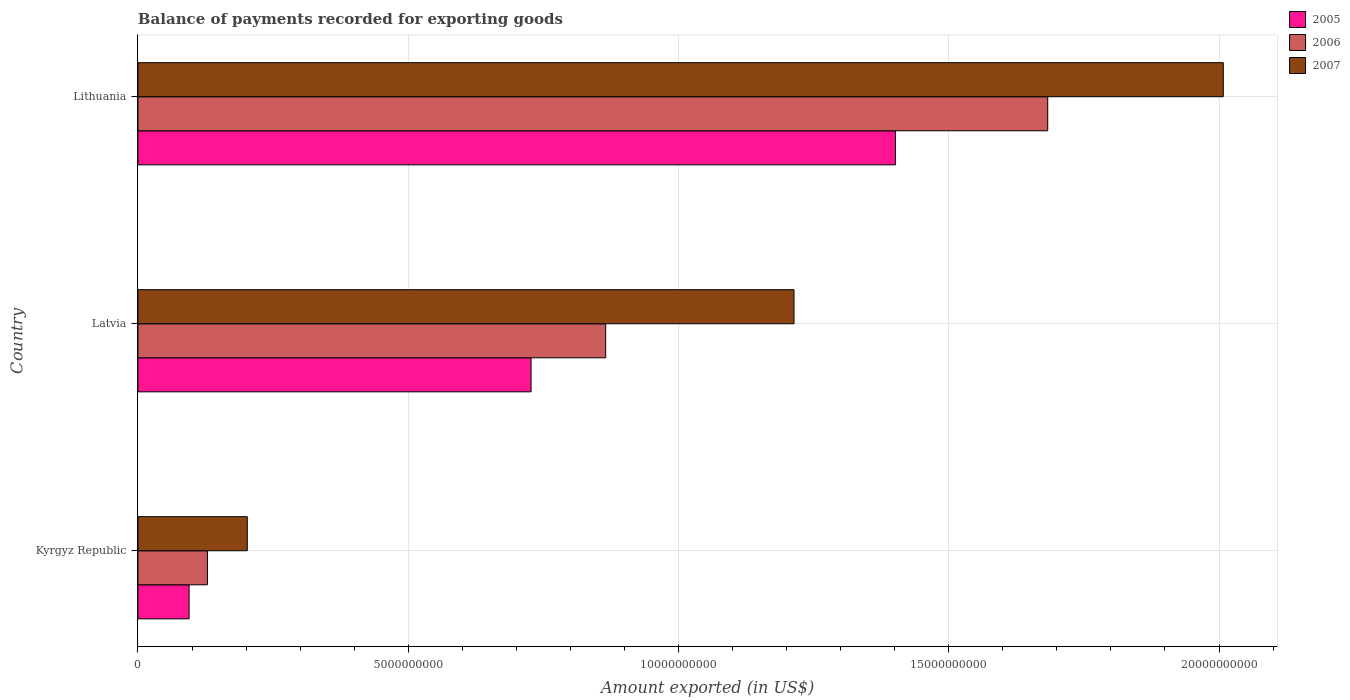How many different coloured bars are there?
Give a very brief answer. 3. Are the number of bars on each tick of the Y-axis equal?
Keep it short and to the point. Yes. How many bars are there on the 1st tick from the top?
Your answer should be compact. 3. What is the label of the 1st group of bars from the top?
Keep it short and to the point. Lithuania. In how many cases, is the number of bars for a given country not equal to the number of legend labels?
Your response must be concise. 0. What is the amount exported in 2005 in Kyrgyz Republic?
Provide a short and direct response. 9.46e+08. Across all countries, what is the maximum amount exported in 2007?
Keep it short and to the point. 2.01e+1. Across all countries, what is the minimum amount exported in 2005?
Offer a terse response. 9.46e+08. In which country was the amount exported in 2007 maximum?
Give a very brief answer. Lithuania. In which country was the amount exported in 2005 minimum?
Provide a succinct answer. Kyrgyz Republic. What is the total amount exported in 2007 in the graph?
Keep it short and to the point. 3.42e+1. What is the difference between the amount exported in 2005 in Kyrgyz Republic and that in Latvia?
Keep it short and to the point. -6.33e+09. What is the difference between the amount exported in 2007 in Kyrgyz Republic and the amount exported in 2005 in Latvia?
Keep it short and to the point. -5.25e+09. What is the average amount exported in 2005 per country?
Your response must be concise. 7.41e+09. What is the difference between the amount exported in 2007 and amount exported in 2006 in Lithuania?
Your response must be concise. 3.25e+09. What is the ratio of the amount exported in 2005 in Latvia to that in Lithuania?
Offer a terse response. 0.52. What is the difference between the highest and the second highest amount exported in 2006?
Keep it short and to the point. 8.18e+09. What is the difference between the highest and the lowest amount exported in 2006?
Offer a terse response. 1.55e+1. In how many countries, is the amount exported in 2006 greater than the average amount exported in 2006 taken over all countries?
Keep it short and to the point. 1. How many countries are there in the graph?
Your answer should be compact. 3. Are the values on the major ticks of X-axis written in scientific E-notation?
Ensure brevity in your answer.  No. Does the graph contain any zero values?
Make the answer very short. No. Where does the legend appear in the graph?
Offer a very short reply. Top right. How many legend labels are there?
Provide a succinct answer. 3. How are the legend labels stacked?
Keep it short and to the point. Vertical. What is the title of the graph?
Offer a terse response. Balance of payments recorded for exporting goods. Does "1960" appear as one of the legend labels in the graph?
Your answer should be very brief. No. What is the label or title of the X-axis?
Ensure brevity in your answer.  Amount exported (in US$). What is the label or title of the Y-axis?
Offer a very short reply. Country. What is the Amount exported (in US$) of 2005 in Kyrgyz Republic?
Your answer should be compact. 9.46e+08. What is the Amount exported (in US$) in 2006 in Kyrgyz Republic?
Your response must be concise. 1.28e+09. What is the Amount exported (in US$) in 2007 in Kyrgyz Republic?
Offer a very short reply. 2.02e+09. What is the Amount exported (in US$) in 2005 in Latvia?
Offer a terse response. 7.27e+09. What is the Amount exported (in US$) in 2006 in Latvia?
Your response must be concise. 8.65e+09. What is the Amount exported (in US$) of 2007 in Latvia?
Give a very brief answer. 1.21e+1. What is the Amount exported (in US$) of 2005 in Lithuania?
Keep it short and to the point. 1.40e+1. What is the Amount exported (in US$) of 2006 in Lithuania?
Provide a succinct answer. 1.68e+1. What is the Amount exported (in US$) of 2007 in Lithuania?
Give a very brief answer. 2.01e+1. Across all countries, what is the maximum Amount exported (in US$) of 2005?
Provide a succinct answer. 1.40e+1. Across all countries, what is the maximum Amount exported (in US$) in 2006?
Offer a terse response. 1.68e+1. Across all countries, what is the maximum Amount exported (in US$) in 2007?
Provide a succinct answer. 2.01e+1. Across all countries, what is the minimum Amount exported (in US$) of 2005?
Your response must be concise. 9.46e+08. Across all countries, what is the minimum Amount exported (in US$) in 2006?
Provide a succinct answer. 1.28e+09. Across all countries, what is the minimum Amount exported (in US$) of 2007?
Provide a short and direct response. 2.02e+09. What is the total Amount exported (in US$) of 2005 in the graph?
Keep it short and to the point. 2.22e+1. What is the total Amount exported (in US$) in 2006 in the graph?
Your answer should be compact. 2.68e+1. What is the total Amount exported (in US$) of 2007 in the graph?
Give a very brief answer. 3.42e+1. What is the difference between the Amount exported (in US$) in 2005 in Kyrgyz Republic and that in Latvia?
Ensure brevity in your answer.  -6.33e+09. What is the difference between the Amount exported (in US$) in 2006 in Kyrgyz Republic and that in Latvia?
Your answer should be compact. -7.37e+09. What is the difference between the Amount exported (in US$) in 2007 in Kyrgyz Republic and that in Latvia?
Your answer should be compact. -1.01e+1. What is the difference between the Amount exported (in US$) in 2005 in Kyrgyz Republic and that in Lithuania?
Keep it short and to the point. -1.31e+1. What is the difference between the Amount exported (in US$) of 2006 in Kyrgyz Republic and that in Lithuania?
Offer a very short reply. -1.55e+1. What is the difference between the Amount exported (in US$) of 2007 in Kyrgyz Republic and that in Lithuania?
Your response must be concise. -1.81e+1. What is the difference between the Amount exported (in US$) of 2005 in Latvia and that in Lithuania?
Ensure brevity in your answer.  -6.74e+09. What is the difference between the Amount exported (in US$) in 2006 in Latvia and that in Lithuania?
Keep it short and to the point. -8.18e+09. What is the difference between the Amount exported (in US$) in 2007 in Latvia and that in Lithuania?
Give a very brief answer. -7.94e+09. What is the difference between the Amount exported (in US$) in 2005 in Kyrgyz Republic and the Amount exported (in US$) in 2006 in Latvia?
Your response must be concise. -7.71e+09. What is the difference between the Amount exported (in US$) in 2005 in Kyrgyz Republic and the Amount exported (in US$) in 2007 in Latvia?
Provide a short and direct response. -1.12e+1. What is the difference between the Amount exported (in US$) of 2006 in Kyrgyz Republic and the Amount exported (in US$) of 2007 in Latvia?
Make the answer very short. -1.09e+1. What is the difference between the Amount exported (in US$) in 2005 in Kyrgyz Republic and the Amount exported (in US$) in 2006 in Lithuania?
Ensure brevity in your answer.  -1.59e+1. What is the difference between the Amount exported (in US$) in 2005 in Kyrgyz Republic and the Amount exported (in US$) in 2007 in Lithuania?
Give a very brief answer. -1.91e+1. What is the difference between the Amount exported (in US$) of 2006 in Kyrgyz Republic and the Amount exported (in US$) of 2007 in Lithuania?
Offer a very short reply. -1.88e+1. What is the difference between the Amount exported (in US$) in 2005 in Latvia and the Amount exported (in US$) in 2006 in Lithuania?
Provide a short and direct response. -9.56e+09. What is the difference between the Amount exported (in US$) in 2005 in Latvia and the Amount exported (in US$) in 2007 in Lithuania?
Your answer should be very brief. -1.28e+1. What is the difference between the Amount exported (in US$) of 2006 in Latvia and the Amount exported (in US$) of 2007 in Lithuania?
Keep it short and to the point. -1.14e+1. What is the average Amount exported (in US$) in 2005 per country?
Your answer should be compact. 7.41e+09. What is the average Amount exported (in US$) in 2006 per country?
Offer a very short reply. 8.92e+09. What is the average Amount exported (in US$) in 2007 per country?
Make the answer very short. 1.14e+1. What is the difference between the Amount exported (in US$) in 2005 and Amount exported (in US$) in 2006 in Kyrgyz Republic?
Provide a short and direct response. -3.38e+08. What is the difference between the Amount exported (in US$) of 2005 and Amount exported (in US$) of 2007 in Kyrgyz Republic?
Provide a short and direct response. -1.08e+09. What is the difference between the Amount exported (in US$) of 2006 and Amount exported (in US$) of 2007 in Kyrgyz Republic?
Offer a very short reply. -7.38e+08. What is the difference between the Amount exported (in US$) of 2005 and Amount exported (in US$) of 2006 in Latvia?
Provide a short and direct response. -1.38e+09. What is the difference between the Amount exported (in US$) of 2005 and Amount exported (in US$) of 2007 in Latvia?
Your answer should be very brief. -4.86e+09. What is the difference between the Amount exported (in US$) in 2006 and Amount exported (in US$) in 2007 in Latvia?
Provide a succinct answer. -3.48e+09. What is the difference between the Amount exported (in US$) in 2005 and Amount exported (in US$) in 2006 in Lithuania?
Keep it short and to the point. -2.82e+09. What is the difference between the Amount exported (in US$) in 2005 and Amount exported (in US$) in 2007 in Lithuania?
Your answer should be compact. -6.07e+09. What is the difference between the Amount exported (in US$) of 2006 and Amount exported (in US$) of 2007 in Lithuania?
Your answer should be compact. -3.25e+09. What is the ratio of the Amount exported (in US$) of 2005 in Kyrgyz Republic to that in Latvia?
Your response must be concise. 0.13. What is the ratio of the Amount exported (in US$) of 2006 in Kyrgyz Republic to that in Latvia?
Provide a short and direct response. 0.15. What is the ratio of the Amount exported (in US$) of 2007 in Kyrgyz Republic to that in Latvia?
Your response must be concise. 0.17. What is the ratio of the Amount exported (in US$) in 2005 in Kyrgyz Republic to that in Lithuania?
Ensure brevity in your answer.  0.07. What is the ratio of the Amount exported (in US$) in 2006 in Kyrgyz Republic to that in Lithuania?
Offer a very short reply. 0.08. What is the ratio of the Amount exported (in US$) in 2007 in Kyrgyz Republic to that in Lithuania?
Offer a very short reply. 0.1. What is the ratio of the Amount exported (in US$) of 2005 in Latvia to that in Lithuania?
Ensure brevity in your answer.  0.52. What is the ratio of the Amount exported (in US$) in 2006 in Latvia to that in Lithuania?
Your answer should be very brief. 0.51. What is the ratio of the Amount exported (in US$) in 2007 in Latvia to that in Lithuania?
Your answer should be very brief. 0.6. What is the difference between the highest and the second highest Amount exported (in US$) of 2005?
Ensure brevity in your answer.  6.74e+09. What is the difference between the highest and the second highest Amount exported (in US$) of 2006?
Your response must be concise. 8.18e+09. What is the difference between the highest and the second highest Amount exported (in US$) of 2007?
Your answer should be very brief. 7.94e+09. What is the difference between the highest and the lowest Amount exported (in US$) in 2005?
Provide a short and direct response. 1.31e+1. What is the difference between the highest and the lowest Amount exported (in US$) in 2006?
Your answer should be very brief. 1.55e+1. What is the difference between the highest and the lowest Amount exported (in US$) in 2007?
Provide a short and direct response. 1.81e+1. 